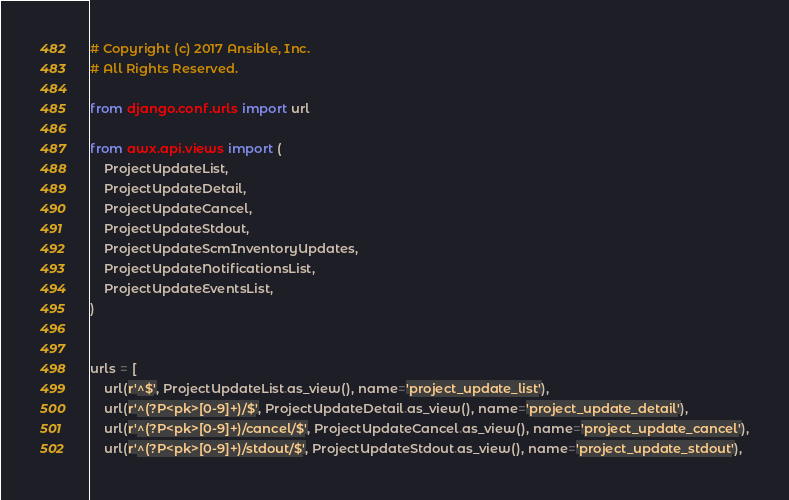Convert code to text. <code><loc_0><loc_0><loc_500><loc_500><_Python_># Copyright (c) 2017 Ansible, Inc.
# All Rights Reserved.

from django.conf.urls import url

from awx.api.views import (
    ProjectUpdateList,
    ProjectUpdateDetail,
    ProjectUpdateCancel,
    ProjectUpdateStdout,
    ProjectUpdateScmInventoryUpdates,
    ProjectUpdateNotificationsList,
    ProjectUpdateEventsList,
)


urls = [
    url(r'^$', ProjectUpdateList.as_view(), name='project_update_list'),
    url(r'^(?P<pk>[0-9]+)/$', ProjectUpdateDetail.as_view(), name='project_update_detail'),
    url(r'^(?P<pk>[0-9]+)/cancel/$', ProjectUpdateCancel.as_view(), name='project_update_cancel'),
    url(r'^(?P<pk>[0-9]+)/stdout/$', ProjectUpdateStdout.as_view(), name='project_update_stdout'),</code> 